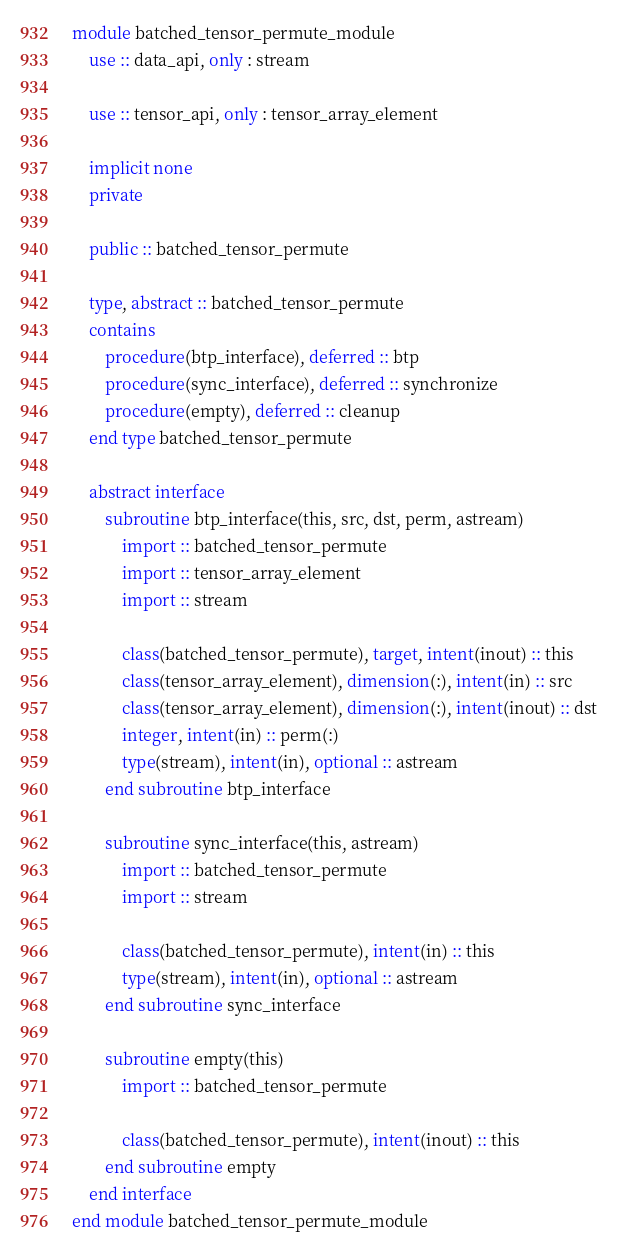<code> <loc_0><loc_0><loc_500><loc_500><_FORTRAN_>module batched_tensor_permute_module
    use :: data_api, only : stream

    use :: tensor_api, only : tensor_array_element

    implicit none
    private

    public :: batched_tensor_permute

    type, abstract :: batched_tensor_permute
    contains
        procedure(btp_interface), deferred :: btp
        procedure(sync_interface), deferred :: synchronize
        procedure(empty), deferred :: cleanup
    end type batched_tensor_permute

    abstract interface
        subroutine btp_interface(this, src, dst, perm, astream)
            import :: batched_tensor_permute
            import :: tensor_array_element
            import :: stream

            class(batched_tensor_permute), target, intent(inout) :: this
            class(tensor_array_element), dimension(:), intent(in) :: src
            class(tensor_array_element), dimension(:), intent(inout) :: dst
            integer, intent(in) :: perm(:)
            type(stream), intent(in), optional :: astream
        end subroutine btp_interface

        subroutine sync_interface(this, astream)
            import :: batched_tensor_permute
            import :: stream

            class(batched_tensor_permute), intent(in) :: this
            type(stream), intent(in), optional :: astream
        end subroutine sync_interface

        subroutine empty(this)
            import :: batched_tensor_permute

            class(batched_tensor_permute), intent(inout) :: this
        end subroutine empty
    end interface
end module batched_tensor_permute_module
</code> 